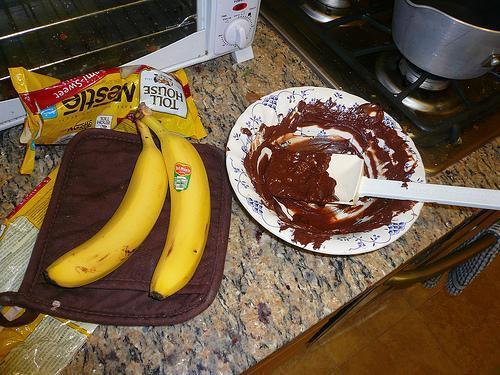How many bananas are there?
Give a very brief answer. 2. How many bananas have a sticker on them?
Give a very brief answer. 1. 